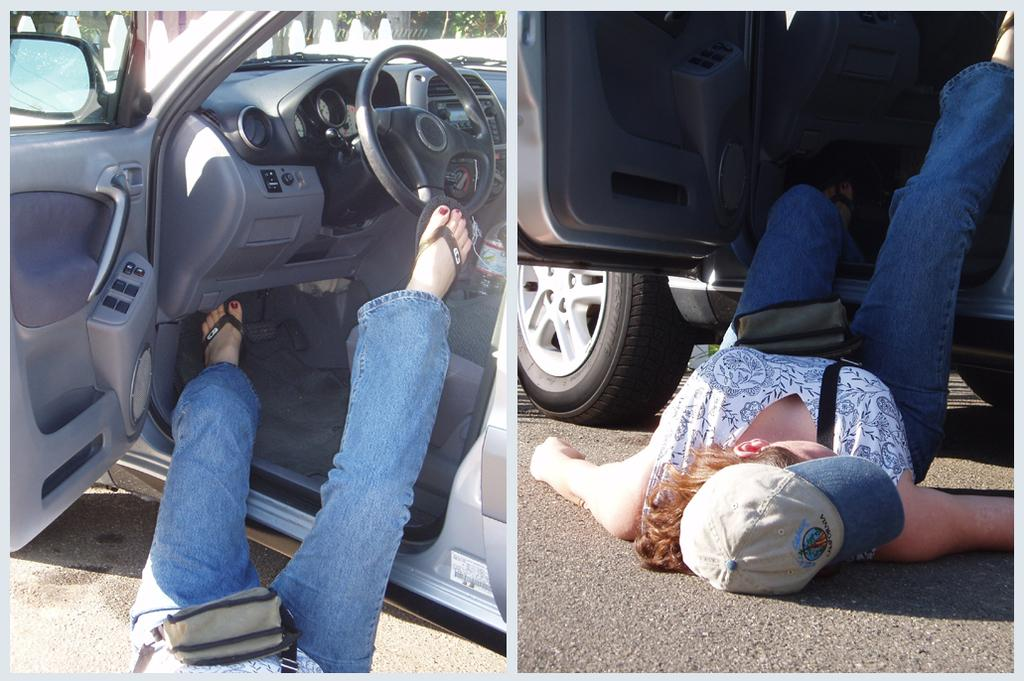What is the composition of the image? The image is a collage of two different pictures. What is happening in both pictures? In both pictures, there is a person falling from a car. How many fans are visible in the image? There are no fans present in the image. How many girls are shown in the image? The image does not depict any girls; it shows two different pictures of a person falling from a car. 